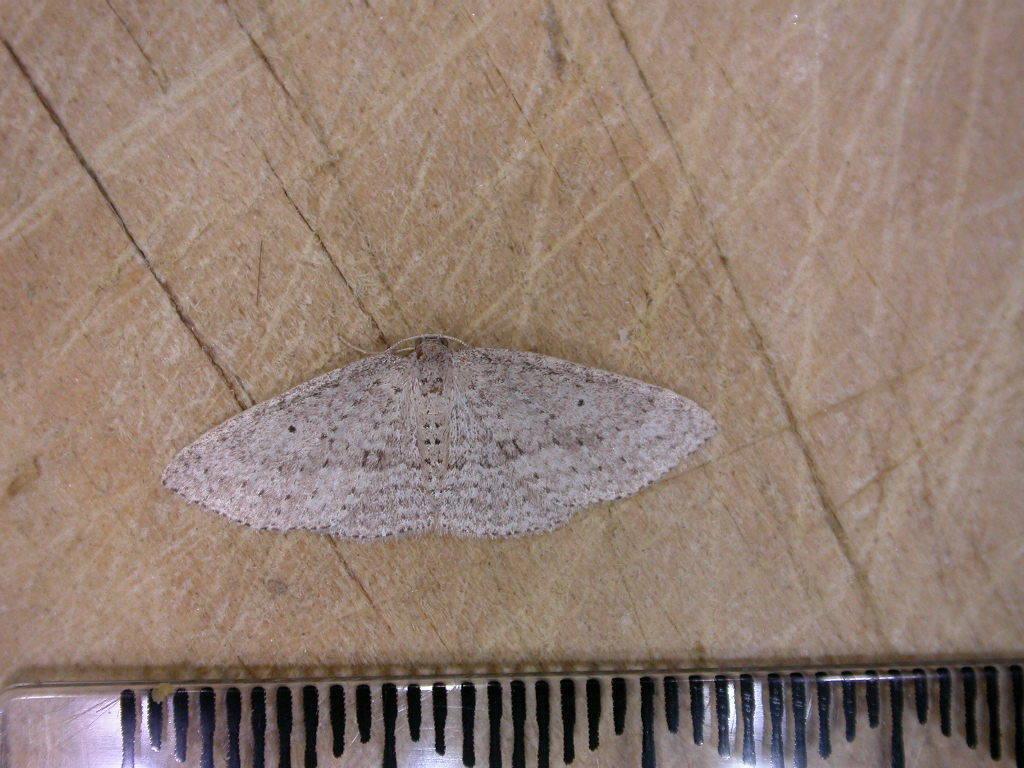Could you give a brief overview of what you see in this image? In this image I can see a butterfly. It is in white and brown color. Butterfly is in wooden board. Bottom I can see a object which is in different color. 